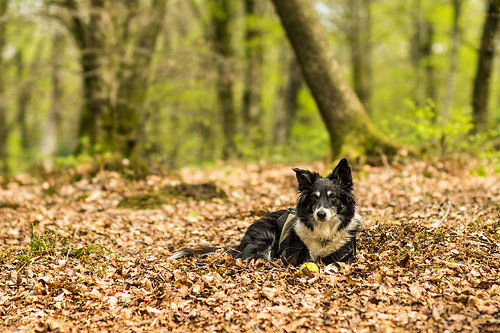<image>
Is the dog in the tree? No. The dog is not contained within the tree. These objects have a different spatial relationship. 